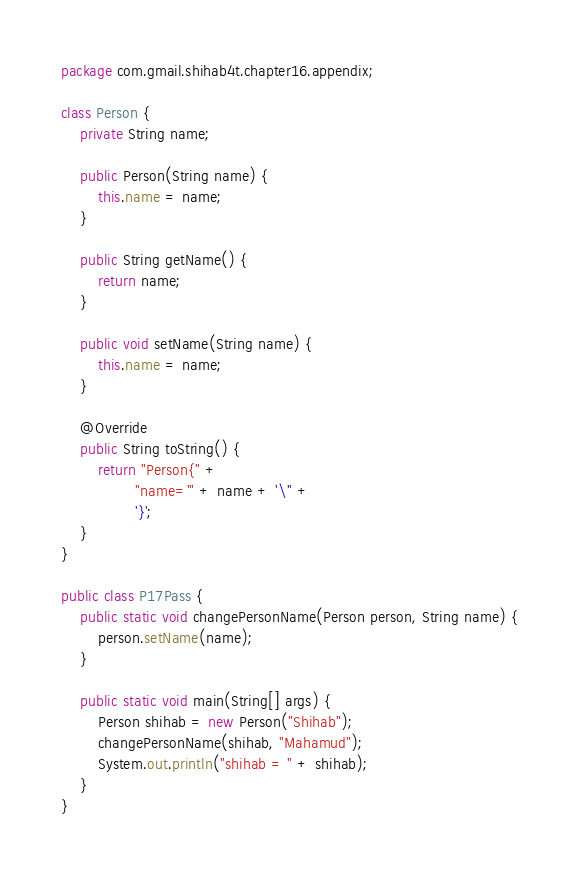Convert code to text. <code><loc_0><loc_0><loc_500><loc_500><_Java_>package com.gmail.shihab4t.chapter16.appendix;

class Person {
    private String name;

    public Person(String name) {
        this.name = name;
    }

    public String getName() {
        return name;
    }

    public void setName(String name) {
        this.name = name;
    }

    @Override
    public String toString() {
        return "Person{" +
                "name='" + name + '\'' +
                '}';
    }
}

public class P17Pass {
    public static void changePersonName(Person person, String name) {
        person.setName(name);
    }

    public static void main(String[] args) {
        Person shihab = new Person("Shihab");
        changePersonName(shihab, "Mahamud");
        System.out.println("shihab = " + shihab);
    }
}
</code> 